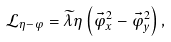Convert formula to latex. <formula><loc_0><loc_0><loc_500><loc_500>\mathcal { L } _ { \eta - \varphi } = \widetilde { \lambda } \eta \left ( \vec { \varphi } _ { x } ^ { 2 } - \vec { \varphi } _ { y } ^ { 2 } \right ) ,</formula> 